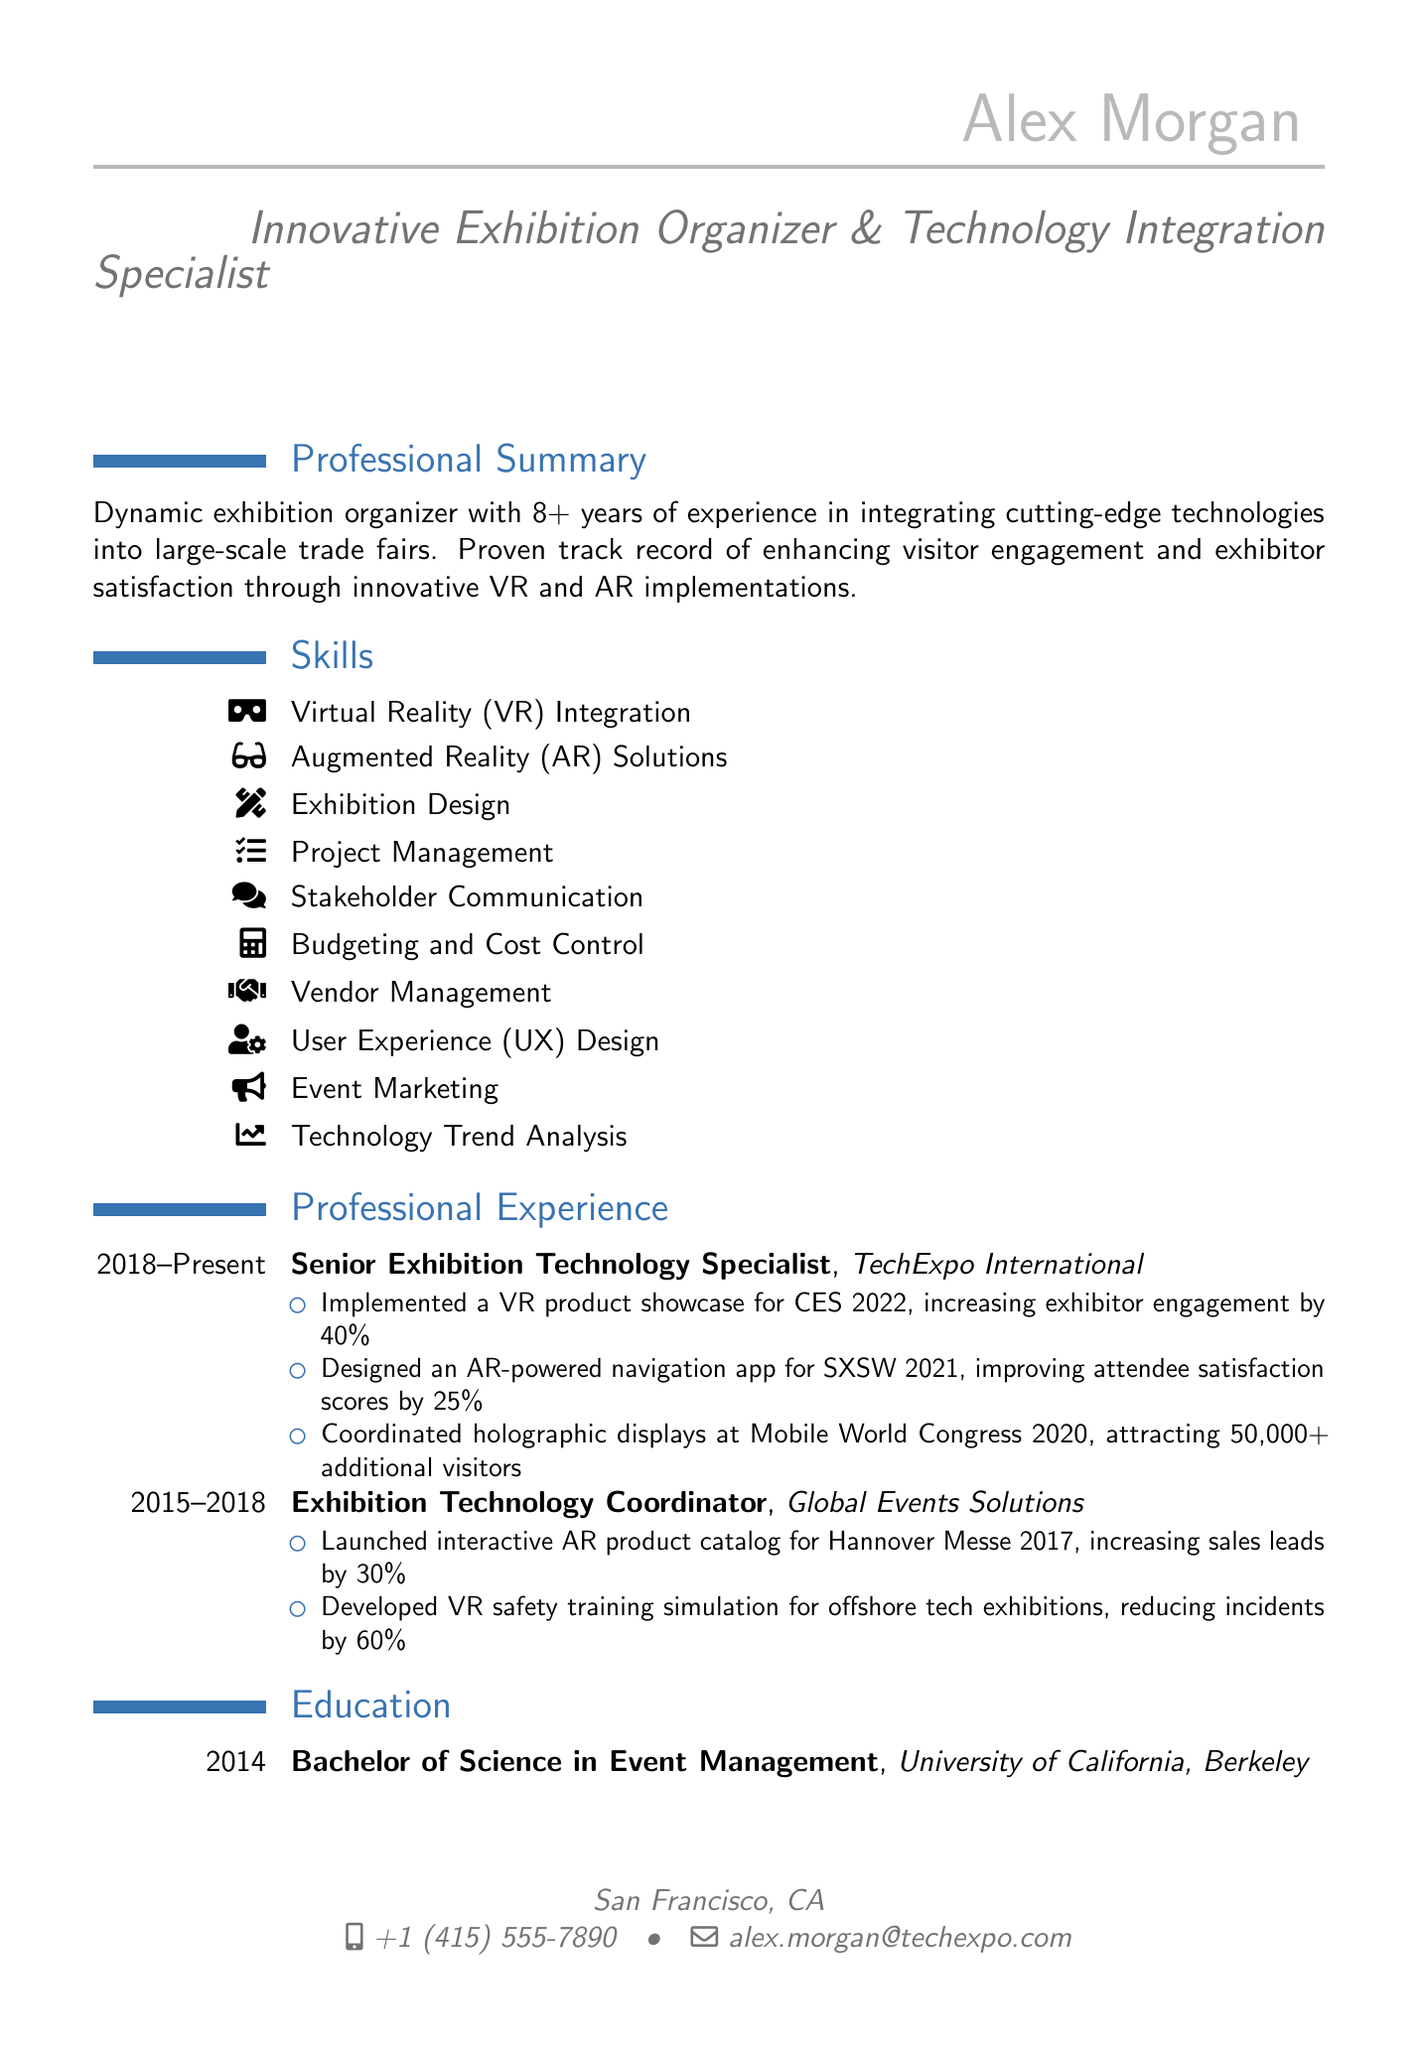What is the name of the individual? The name of the individual is listed at the beginning of the document.
Answer: Alex Morgan What title does Alex Morgan hold? The title appears prominently under the name in the document.
Answer: Innovative Exhibition Organizer & Technology Integration Specialist How many years of experience does Alex have? The number of years of experience is mentioned in the professional summary section.
Answer: 8+ What company did Alex work for from 2015 to 2018? The document contains information about Alex's employment history under professional experience.
Answer: Global Events Solutions What was the percentage increase in exhibitor engagement from the VR product showcase at CES 2022? This specific achievement is noted under the experience section for Alex's current role.
Answer: 40% Which event featured an AR-powered navigation app? This information is found in the list of achievements under Alex's current job.
Answer: SXSW 2021 What is the certification related to exhibition management that Alex holds? The relevant certification is listed in the certifications section.
Answer: Certified in Exhibition Management (CEM) How much did incidents reduce by with the VR safety training simulation? The document states this statistic in the achievements of Alex's previous role.
Answer: 60% What major technology did Alex coordinate at Mobile World Congress 2020? This information is found in the achievements under professional experience.
Answer: Holographic displays 